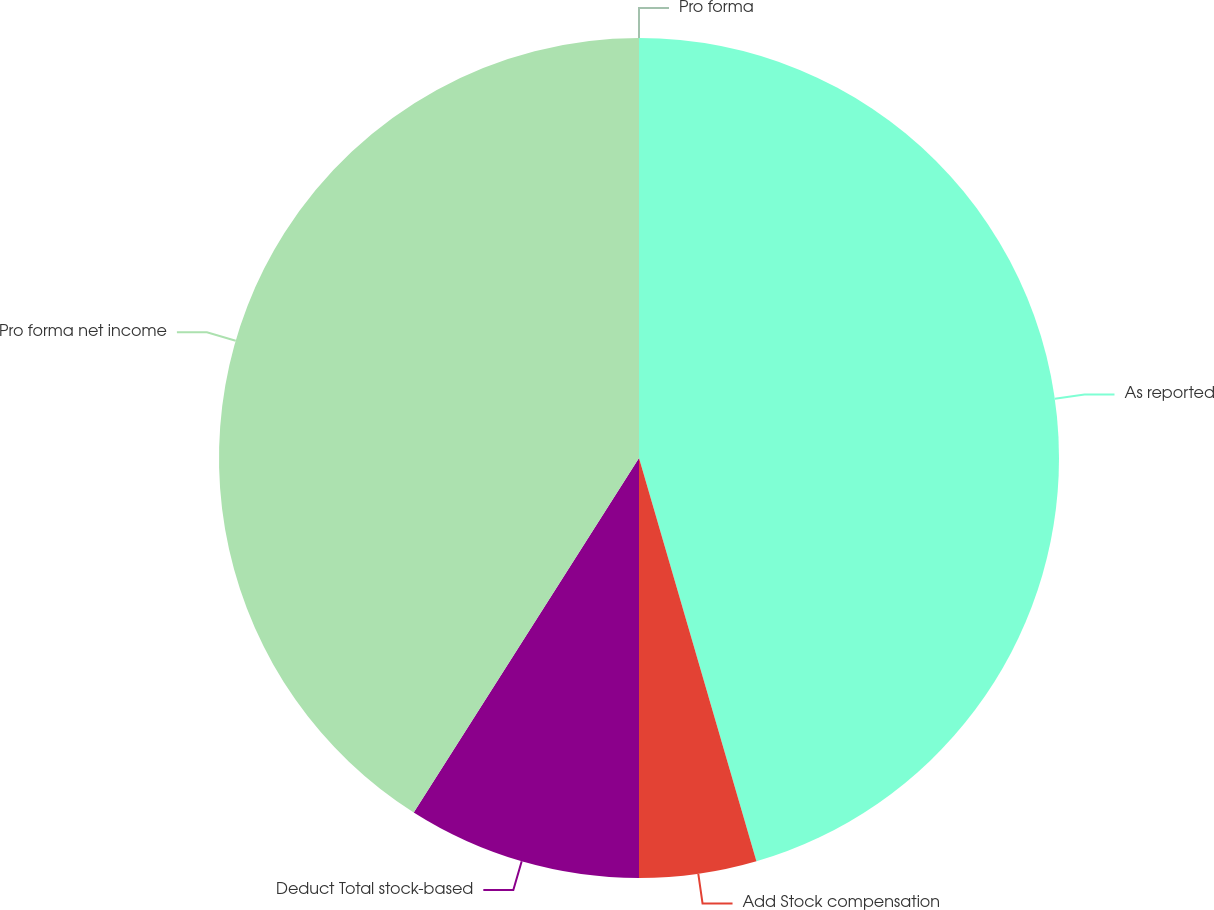<chart> <loc_0><loc_0><loc_500><loc_500><pie_chart><fcel>As reported<fcel>Add Stock compensation<fcel>Deduct Total stock-based<fcel>Pro forma net income<fcel>Pro forma<nl><fcel>45.49%<fcel>4.51%<fcel>9.01%<fcel>40.99%<fcel>0.0%<nl></chart> 